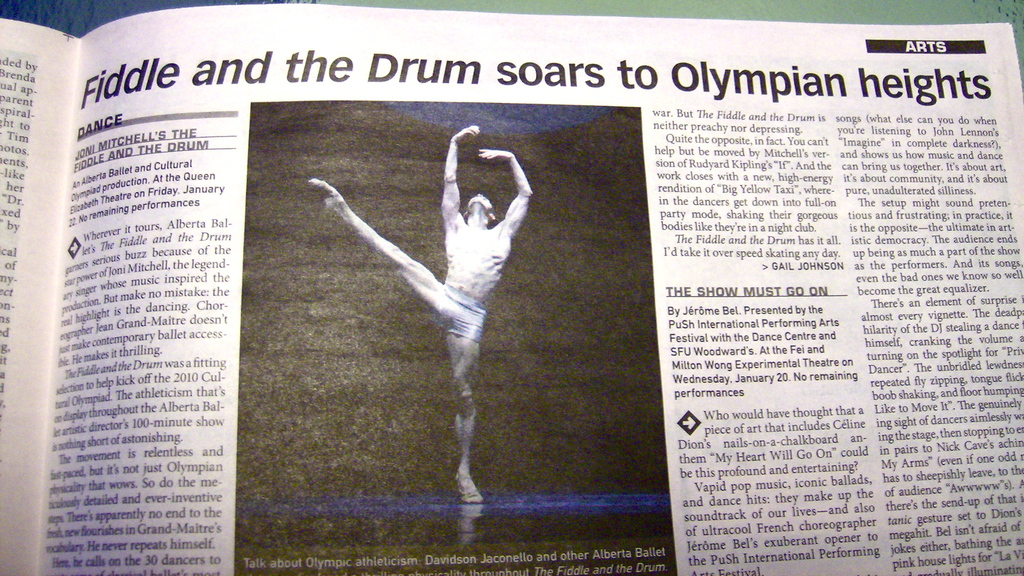Provide a one-sentence caption for the provided image.
Reference OCR token: Fiddle, and, the, Drum, soars, to, Olympian, heights, nspired, SHOW, GOON, wasafitting, 2010Cul-, Wednesday,, Olympian, faudience, fultracool, exuberant, opener, Ballet, Olympi, athleticism, Internationa, Performing A newspaper article in the arts section with a picture of a male ballet dancer on it. 